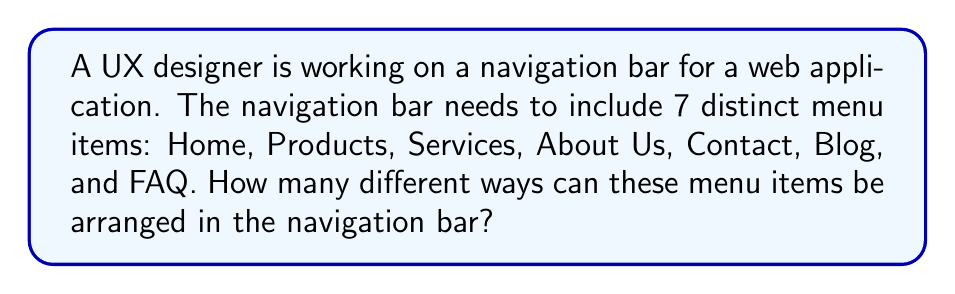Teach me how to tackle this problem. To solve this problem, we need to use the concept of permutations from combinatorics. Since we have 7 distinct menu items and we want to arrange all of them in the navigation bar, this is a straightforward permutation problem.

The number of permutations of n distinct objects is given by $n!$ (n factorial).

In this case:
1. We have 7 distinct menu items.
2. We want to arrange all 7 items.
3. The order matters (different arrangements are considered different outcomes).

Therefore, the number of ways to arrange the menu items is:

$$7! = 7 \times 6 \times 5 \times 4 \times 3 \times 2 \times 1 = 5040$$

This means there are 5040 different ways to arrange the 7 menu items in the navigation bar.

For the UX designer, this information could be valuable in understanding the vast number of possible layouts and potentially in deciding whether to implement a customizable navigation bar feature for users.
Answer: $7! = 5040$ 